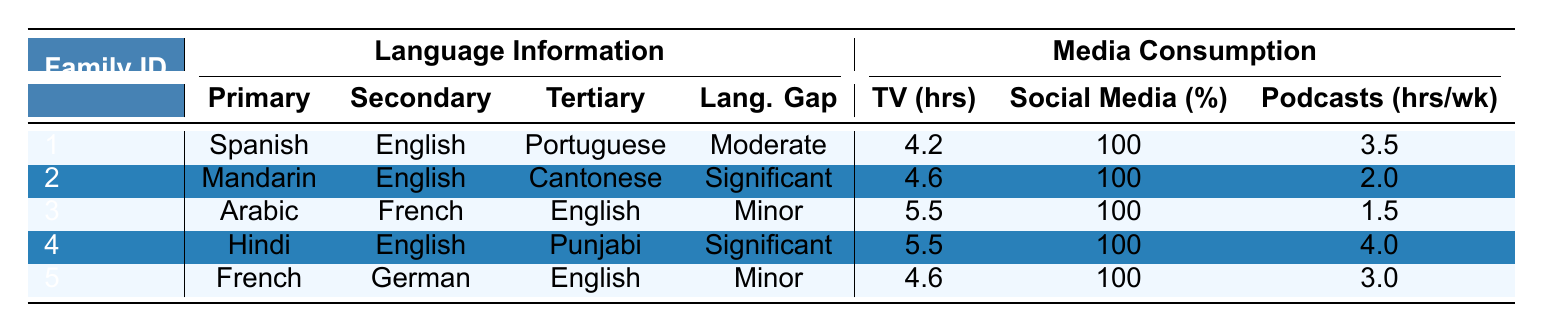What is the primary language of Family ID 3? According to the table, Family ID 3 has Arabic listed as the Primary Language.
Answer: Arabic Which family has the highest daily TV hours for the primary language? By comparing the Daily TV Hours Primary column, Family ID 3 has the highest value at 3.2 hours.
Answer: Family ID 3 What are the preferred news sources for Family ID 5 in both primary and secondary languages? The table shows that Family ID 5 prefers France 24 as the Primary news source and Deutsche Welle as the Secondary news source.
Answer: France 24, Deutsche Welle Is there a family that consumes more than 3 hours of podcasts weekly? Checking the Podcast Consumption Hours Weekly, the highest is 4.0 hours (Family ID 4). Therefore, the answer is yes, Family ID 4 consumes more than 3 hours.
Answer: Yes Which family has the lowest social media usage in the primary language? The Social Media Usage Primary column shows Family ID 3 has the lowest percentage at 55%.
Answer: Family ID 3 What is the average number of cultural events attended per year across all families? We sum the Cultural Events Attendance Per Year (8 + 6 + 10 + 12 + 7 = 43) and divide by the number of families (5), so the average is 43 / 5 = 8.6.
Answer: 8.6 Do families with a significant intergenerational language gap tend to have higher daily TV hours? Families with significant gaps (Family ID 2 and 4) have daily TV hours of 4.6 and 5.5 respectively, both are higher than the average of the entire table. Hence, it appears true.
Answer: Yes Which family reads more books in their primary language, Family ID 1 or Family ID 4? Family ID 1 reads 15 books and Family ID 4 reads 18 books in their primary language. Since 18 is greater than 15, Family ID 4 reads more.
Answer: Family ID 4 How many different languages does Family ID 1 use based on the table? Family ID 1 uses three languages: Spanish as the Primary, English as the Secondary, and Portuguese as the Tertiary.
Answer: Three What is the relationship between preferred streaming services and primary languages in the table? The preferred streaming services do not correlate directly with the primary languages but rather reflect cultural content preferences, which vary across families.
Answer: No direct correlation 